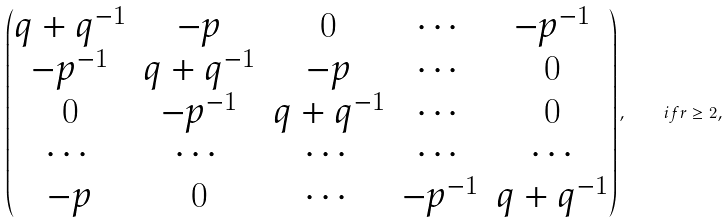<formula> <loc_0><loc_0><loc_500><loc_500>\begin{pmatrix} q + q ^ { - 1 } & - p & 0 & \cdots & - p ^ { - 1 } \\ - p ^ { - 1 } & q + q ^ { - 1 } & - p & \cdots & 0 \\ 0 & - p ^ { - 1 } & q + q ^ { - 1 } & \cdots & 0 \\ \cdots & \cdots & \cdots & \cdots & \cdots \\ - p & 0 & \cdots & - p ^ { - 1 } & q + q ^ { - 1 } \end{pmatrix} , \quad i f r \geq 2 ,</formula> 